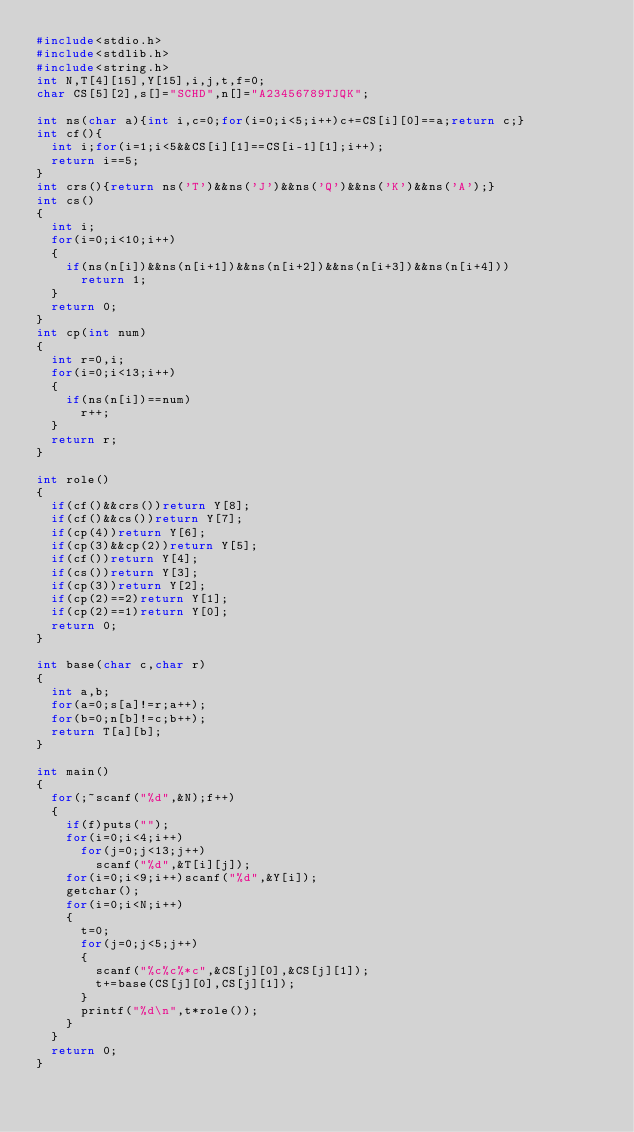<code> <loc_0><loc_0><loc_500><loc_500><_C_>#include<stdio.h>
#include<stdlib.h>
#include<string.h>
int N,T[4][15],Y[15],i,j,t,f=0;
char CS[5][2],s[]="SCHD",n[]="A23456789TJQK";

int ns(char a){int i,c=0;for(i=0;i<5;i++)c+=CS[i][0]==a;return c;}
int cf(){
	int i;for(i=1;i<5&&CS[i][1]==CS[i-1][1];i++);
	return i==5;
}
int crs(){return ns('T')&&ns('J')&&ns('Q')&&ns('K')&&ns('A');}
int cs()
{
	int i;
	for(i=0;i<10;i++)
	{
		if(ns(n[i])&&ns(n[i+1])&&ns(n[i+2])&&ns(n[i+3])&&ns(n[i+4]))
			return 1;
	}
	return 0;
}
int cp(int num)
{
	int r=0,i;
	for(i=0;i<13;i++)
	{
		if(ns(n[i])==num)
			r++;
	}
	return r;
}

int role()
{
	if(cf()&&crs())return Y[8];
	if(cf()&&cs())return Y[7];
	if(cp(4))return Y[6];
	if(cp(3)&&cp(2))return Y[5];
	if(cf())return Y[4];
	if(cs())return Y[3];
	if(cp(3))return Y[2];
	if(cp(2)==2)return Y[1];
	if(cp(2)==1)return Y[0];
	return 0;
}

int base(char c,char r)
{
	int a,b;
	for(a=0;s[a]!=r;a++);
	for(b=0;n[b]!=c;b++);
	return T[a][b];
}

int main()
{
	for(;~scanf("%d",&N);f++)
	{
		if(f)puts("");
		for(i=0;i<4;i++)
			for(j=0;j<13;j++)
				scanf("%d",&T[i][j]);
		for(i=0;i<9;i++)scanf("%d",&Y[i]);
		getchar();
		for(i=0;i<N;i++)
		{
			t=0;
			for(j=0;j<5;j++)
			{
				scanf("%c%c%*c",&CS[j][0],&CS[j][1]);
				t+=base(CS[j][0],CS[j][1]);
			}
			printf("%d\n",t*role());
		}
	}
	return 0;
}</code> 